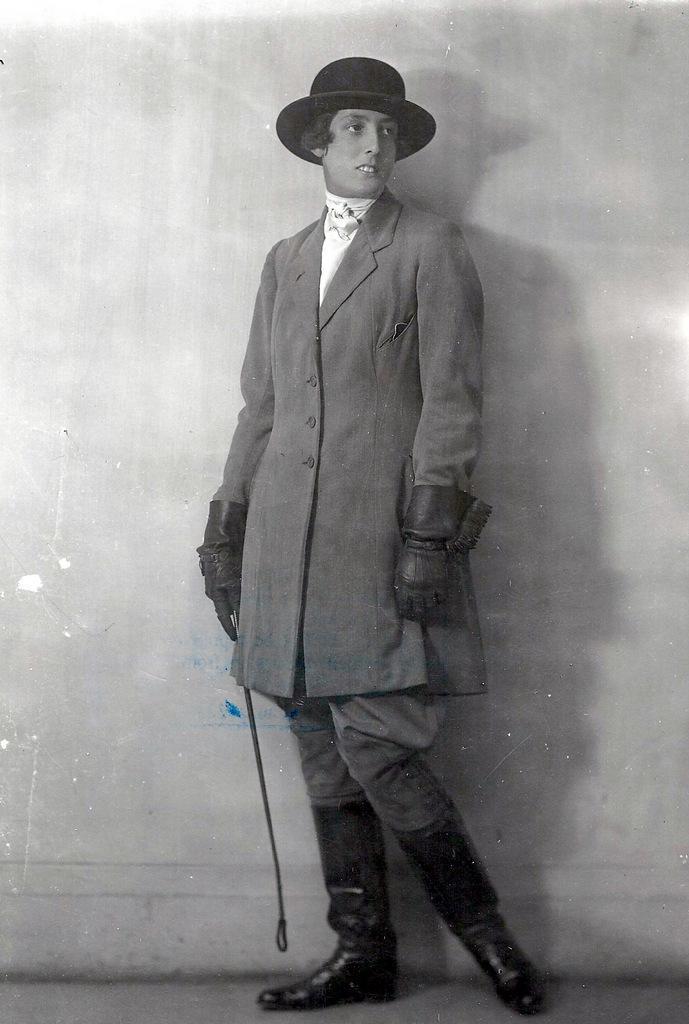How would you summarize this image in a sentence or two? By seeing image we can say it is a photograph. In this image we can see a person is standing and holding something in his hand. 